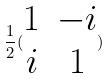<formula> <loc_0><loc_0><loc_500><loc_500>\frac { 1 } { 2 } ( \begin{matrix} 1 & - i \\ i & 1 \end{matrix} )</formula> 